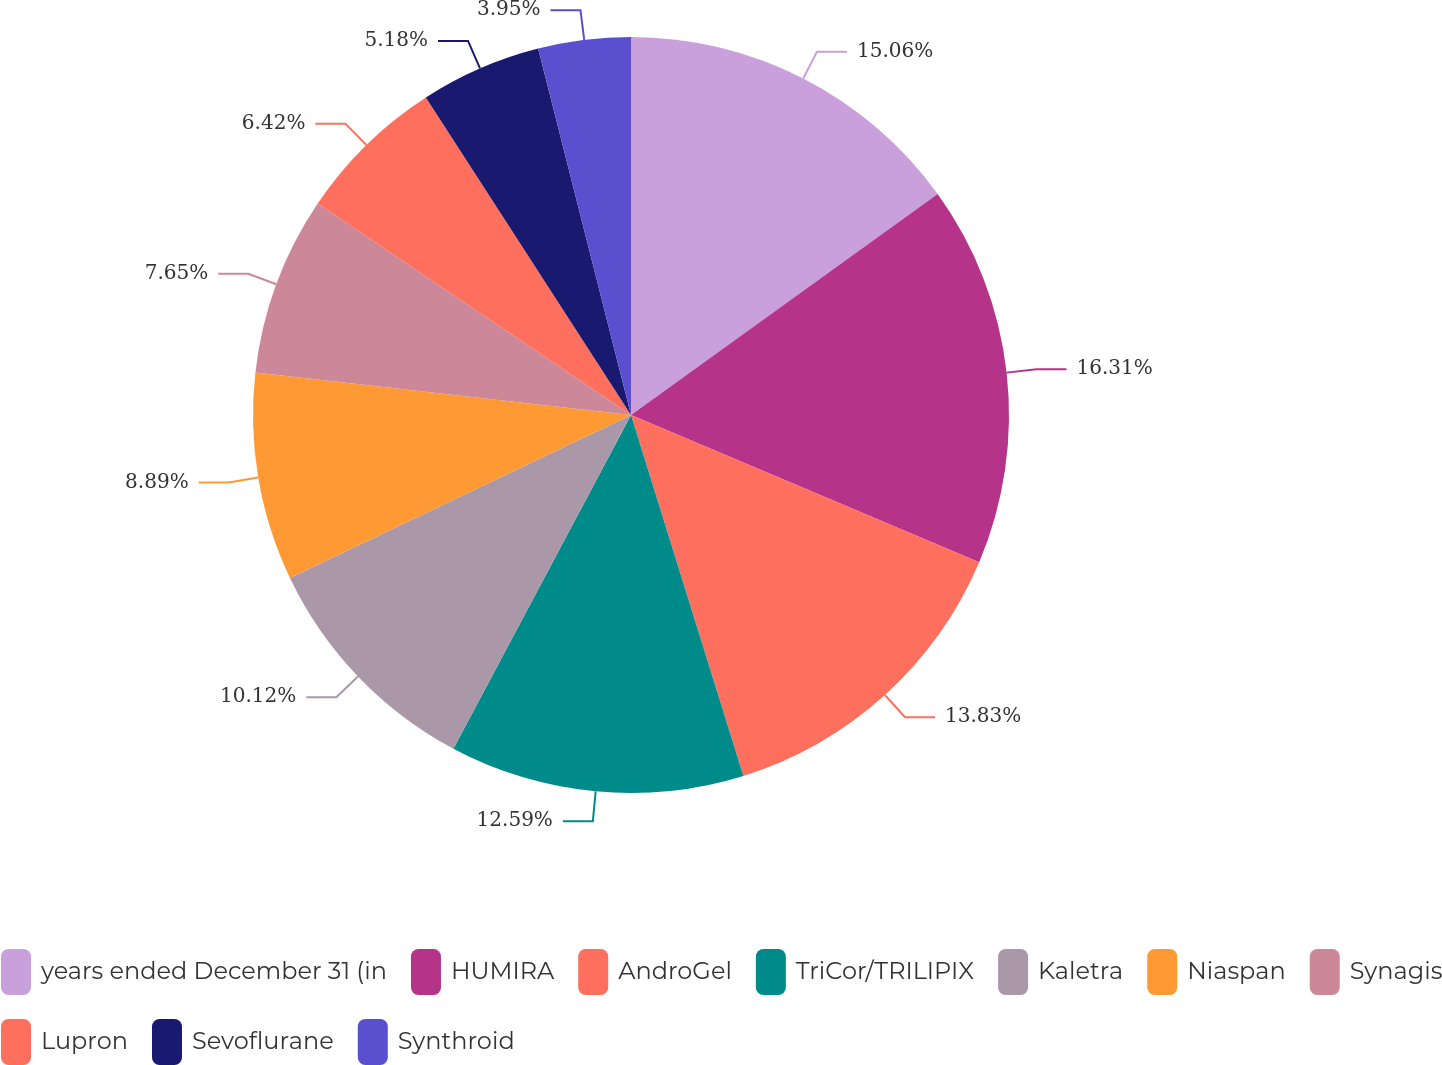Convert chart to OTSL. <chart><loc_0><loc_0><loc_500><loc_500><pie_chart><fcel>years ended December 31 (in<fcel>HUMIRA<fcel>AndroGel<fcel>TriCor/TRILIPIX<fcel>Kaletra<fcel>Niaspan<fcel>Synagis<fcel>Lupron<fcel>Sevoflurane<fcel>Synthroid<nl><fcel>15.06%<fcel>16.3%<fcel>13.83%<fcel>12.59%<fcel>10.12%<fcel>8.89%<fcel>7.65%<fcel>6.42%<fcel>5.18%<fcel>3.95%<nl></chart> 